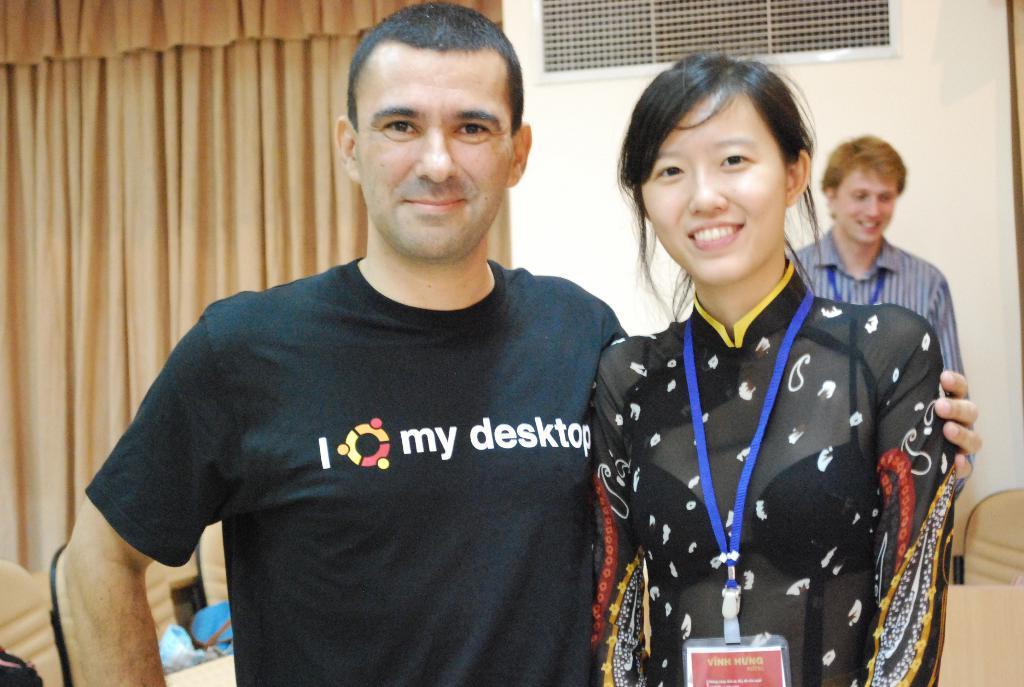Does his shirt say something?
Give a very brief answer. Yes. 